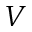Convert formula to latex. <formula><loc_0><loc_0><loc_500><loc_500>V</formula> 